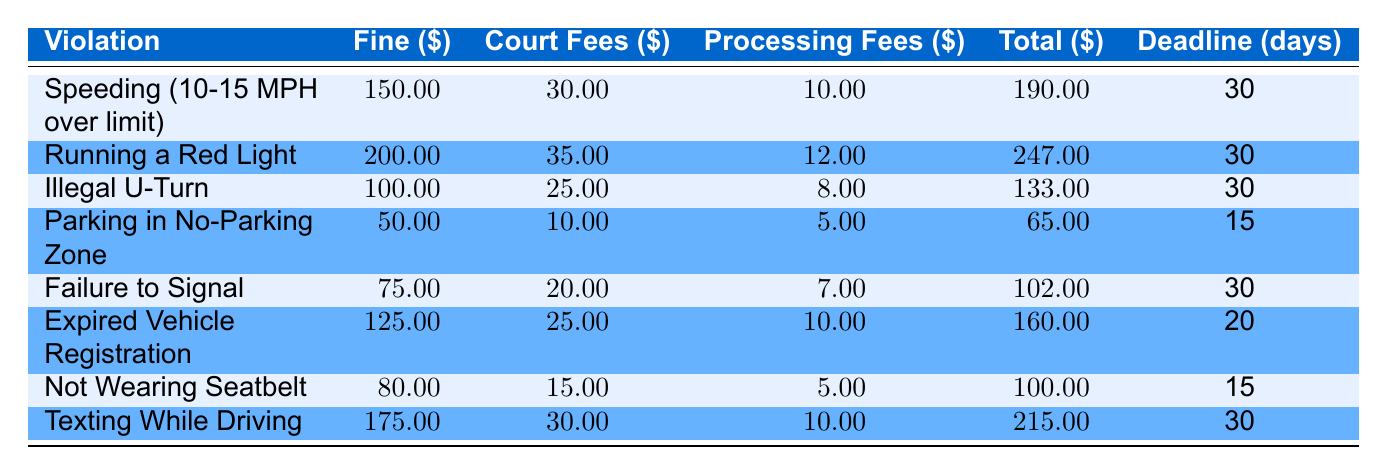What is the total cost for running a red light? The total cost for running a red light can be found in the corresponding row of the table. The total cost listed is 247.00.
Answer: 247.00 How many days do you have to pay for parking in a no-parking zone? The payment deadline for parking in a no-parking zone is provided in the table. It states that you have 15 days to pay the fine.
Answer: 15 days What is the fine amount for not wearing a seatbelt? By referring to the specific row for not wearing a seatbelt in the table, the fine amount is found to be 80.00.
Answer: 80.00 Is the processing fee for failure to signal higher than for illegal U-turn? The processing fee for failure to signal is 7.00, while for illegal U-turn, it is 8.00. Since 7.00 is not higher than 8.00, the statement is false.
Answer: No What is the total of the fines for all violations combined? To find the total of the fines, we can add the fine amounts for all violations: 150 + 200 + 100 + 50 + 75 + 125 + 80 + 175 = 975.
Answer: 975 How much more is the total cost of texting while driving compared to parking in a no-parking zone? The total cost for texting while driving is 215.00 and for parking in a no-parking zone is 65.00. To find the difference, we subtract: 215.00 - 65.00 = 150.00.
Answer: 150.00 Which violation has the highest total cost? By reviewing the total cost column in the table, we identify the highest total cost. The violation 'Running a Red Light' has the highest total cost of 247.00.
Answer: Running a Red Light What is the average fine amount across all violations listed? We first find the total of all fines: 975.00 (from previous calculation) and divide it by the number of violations, which is 8. Therefore, the average fine amount is 975.00 / 8 = 121.875.
Answer: 121.88 